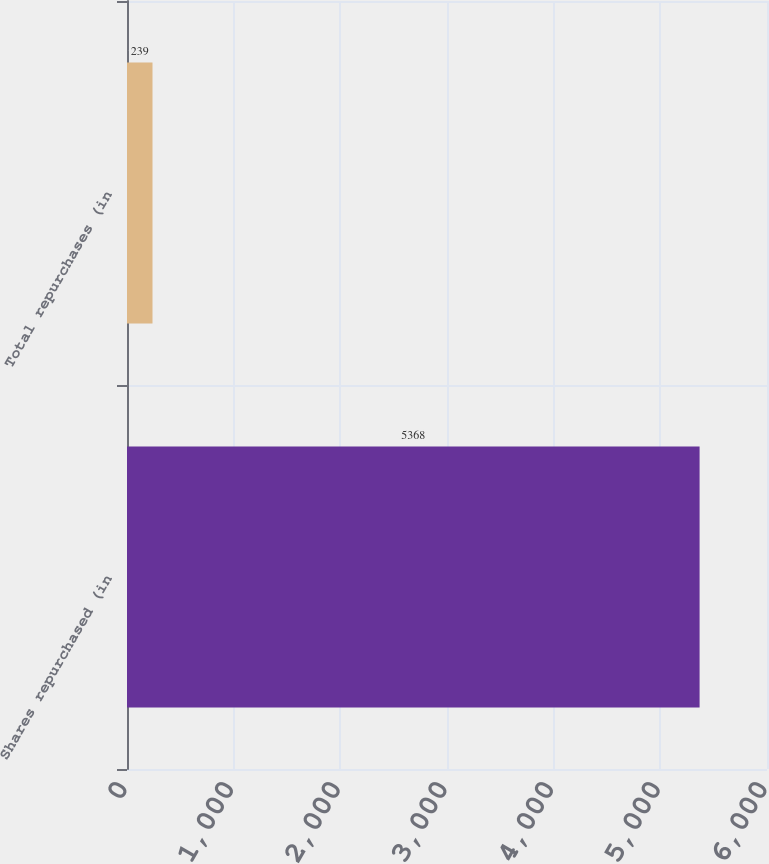Convert chart to OTSL. <chart><loc_0><loc_0><loc_500><loc_500><bar_chart><fcel>Shares repurchased (in<fcel>Total repurchases (in<nl><fcel>5368<fcel>239<nl></chart> 